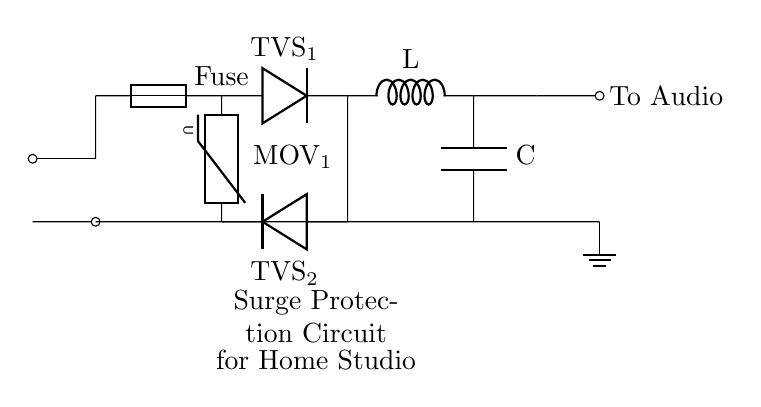what is the type of the first protection component in the circuit? The first protection component in the circuit is labeled as "Fuse." It is used to protect the circuit from excessive current.
Answer: Fuse how many TVS diodes are present in the circuit? The circuit includes two TVS diodes, labeled as "TVS_1" and "TVS_2," positioned across the MOV for voltage suppression.
Answer: 2 what component is added in series after the TVS diodes? The component added in series after the TVS diodes is an inductor, which is marked as "L" in the circuit. Its purpose is to reduce high-frequency noise.
Answer: Inductor what is the purpose of the MOV in the circuit? The MOV (Metal-Oxide Varistor) is designed to absorb voltage spikes, protecting the downstream components from transient voltage surges that can damage equipment.
Answer: Absorb voltage spikes where does the output from this circuit go? The output from this circuit is directed to the audio equipment, indicated by the label "To Audio" in the circuit diagram. This connection ensures the equipment receives protected power.
Answer: To Audio 